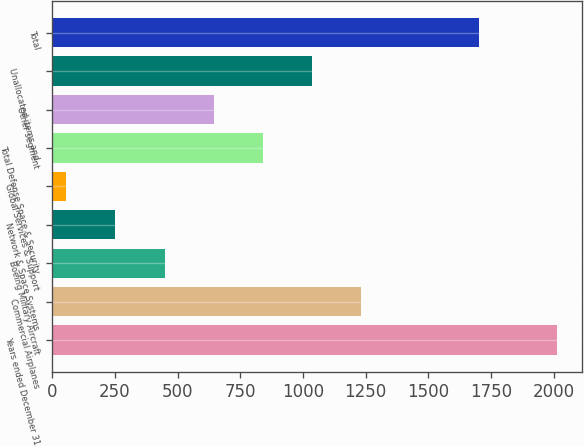<chart> <loc_0><loc_0><loc_500><loc_500><bar_chart><fcel>Years ended December 31<fcel>Commercial Airplanes<fcel>Boeing Military Aircraft<fcel>Network & Space Systems<fcel>Global Services & Support<fcel>Total Defense Space & Security<fcel>Other segment<fcel>Unallocated items and<fcel>Total<nl><fcel>2012<fcel>1230<fcel>448<fcel>252.5<fcel>57<fcel>839<fcel>643.5<fcel>1034.5<fcel>1703<nl></chart> 